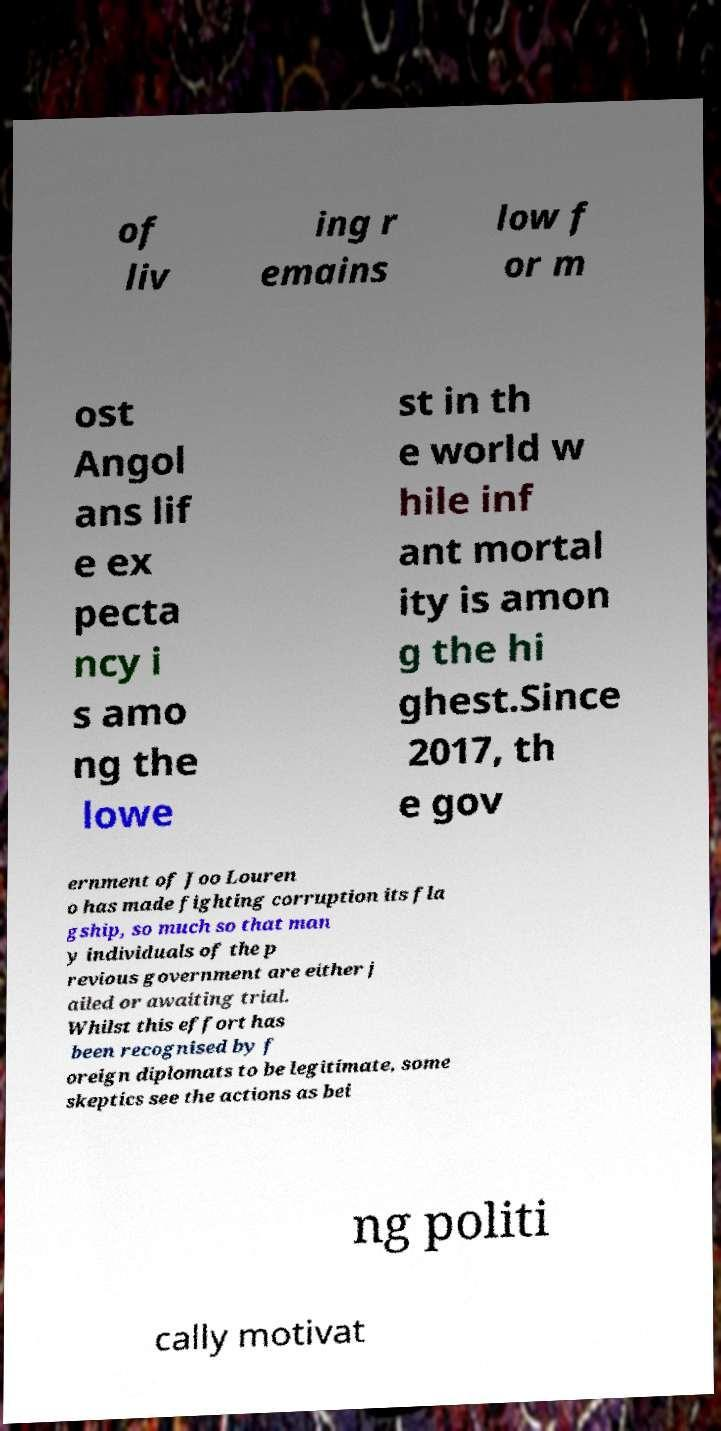Could you assist in decoding the text presented in this image and type it out clearly? of liv ing r emains low f or m ost Angol ans lif e ex pecta ncy i s amo ng the lowe st in th e world w hile inf ant mortal ity is amon g the hi ghest.Since 2017, th e gov ernment of Joo Louren o has made fighting corruption its fla gship, so much so that man y individuals of the p revious government are either j ailed or awaiting trial. Whilst this effort has been recognised by f oreign diplomats to be legitimate, some skeptics see the actions as bei ng politi cally motivat 